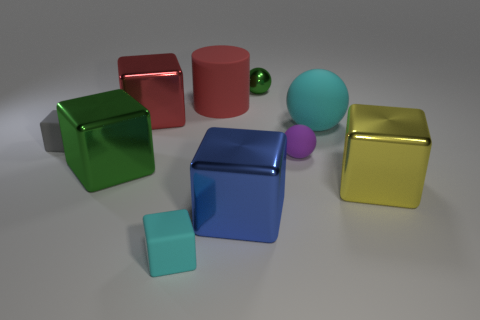There is a cube that is the same color as the small metal sphere; what is its material?
Make the answer very short. Metal. How many things are either red objects in front of the rubber cylinder or matte things that are in front of the red shiny thing?
Make the answer very short. 5. Is the number of large blue cubes that are in front of the small cyan object greater than the number of large red cubes?
Offer a terse response. No. How many other objects are there of the same shape as the yellow metallic object?
Make the answer very short. 5. There is a cube that is in front of the red shiny thing and behind the large green thing; what material is it made of?
Provide a short and direct response. Rubber. What number of objects are cyan rubber balls or purple rubber spheres?
Offer a very short reply. 2. Is the number of purple rubber cylinders greater than the number of matte cylinders?
Offer a terse response. No. There is a matte sphere that is in front of the small matte block that is to the left of the green block; how big is it?
Offer a terse response. Small. There is another large rubber thing that is the same shape as the purple matte thing; what is its color?
Ensure brevity in your answer.  Cyan. The gray matte thing has what size?
Your answer should be compact. Small. 